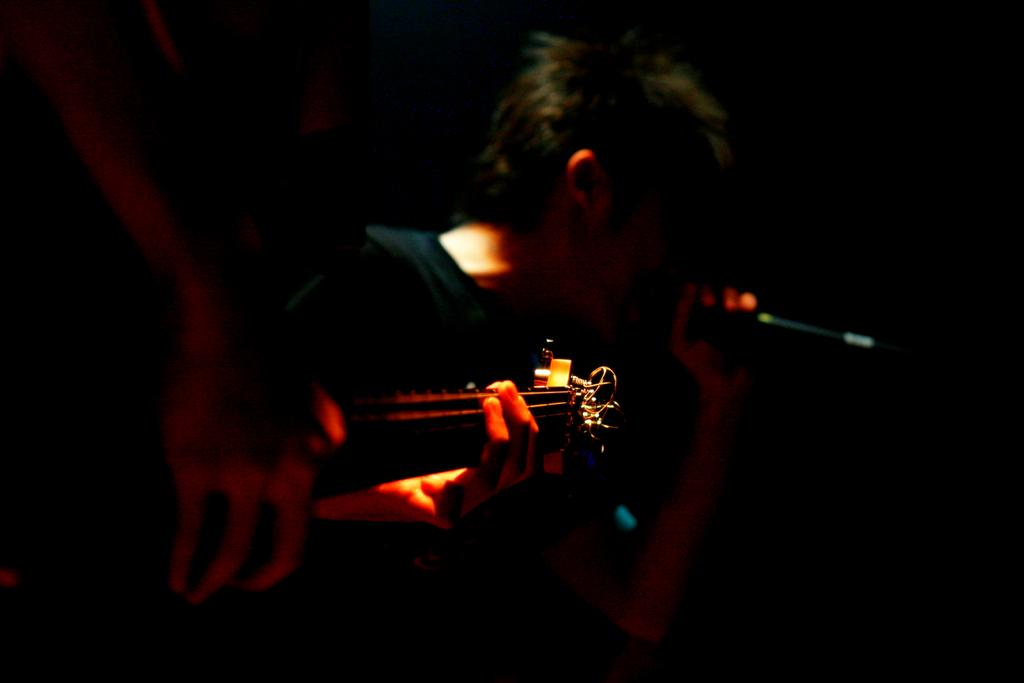What is the person on the left side of the image doing? The person on the left side of the image is playing a guitar. What is the person in the center of the image doing? The person in the center of the image is singing. What can be observed about the lighting in the image? The background of the image is dark. What type of zinc object can be seen in the hands of the person playing the guitar? There is no zinc object present in the image. Can you describe the hen that is perched on the guitarist's shoulder in the image? There is no hen present in the image; the person is playing a guitar without any additional objects or animals. 